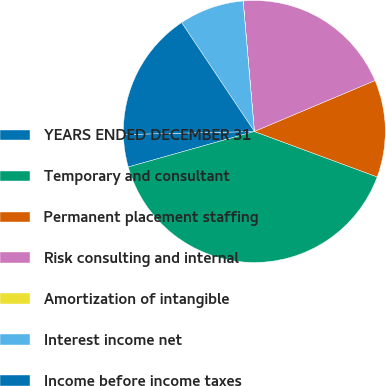Convert chart to OTSL. <chart><loc_0><loc_0><loc_500><loc_500><pie_chart><fcel>YEARS ENDED DECEMBER 31<fcel>Temporary and consultant<fcel>Permanent placement staffing<fcel>Risk consulting and internal<fcel>Amortization of intangible<fcel>Interest income net<fcel>Income before income taxes<nl><fcel>4.0%<fcel>39.99%<fcel>12.0%<fcel>20.0%<fcel>0.01%<fcel>8.0%<fcel>16.0%<nl></chart> 